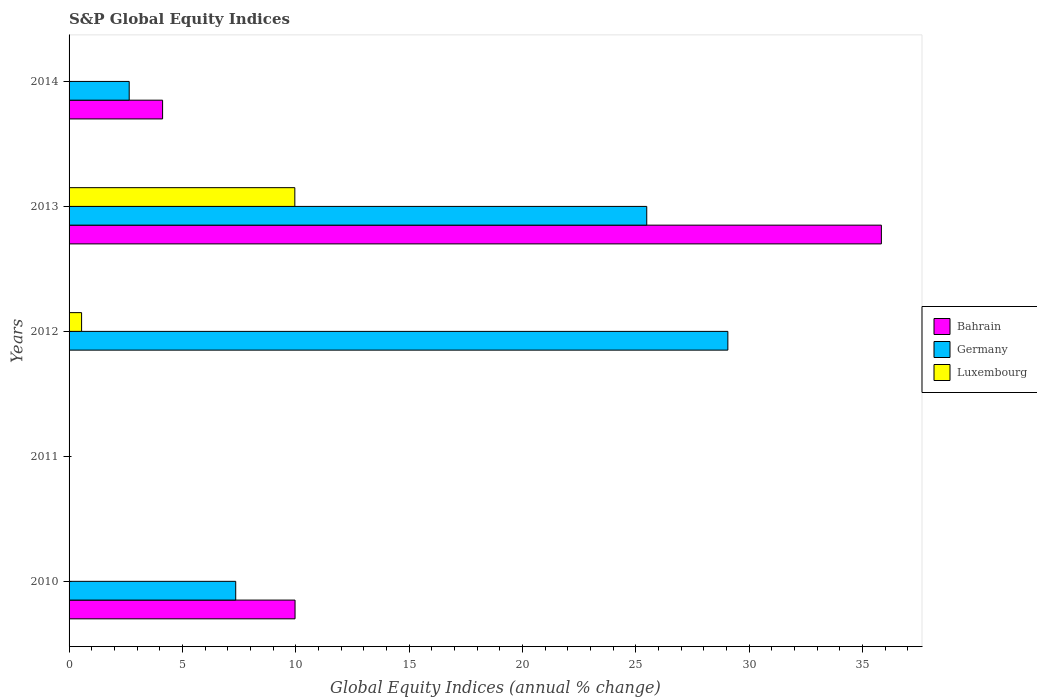In how many cases, is the number of bars for a given year not equal to the number of legend labels?
Provide a succinct answer. 4. Across all years, what is the maximum global equity indices in Germany?
Make the answer very short. 29.06. Across all years, what is the minimum global equity indices in Luxembourg?
Give a very brief answer. 0. In which year was the global equity indices in Luxembourg maximum?
Provide a succinct answer. 2013. What is the total global equity indices in Bahrain in the graph?
Keep it short and to the point. 49.92. What is the difference between the global equity indices in Germany in 2012 and that in 2014?
Provide a short and direct response. 26.41. What is the difference between the global equity indices in Bahrain in 2014 and the global equity indices in Luxembourg in 2012?
Offer a very short reply. 3.57. What is the average global equity indices in Germany per year?
Offer a very short reply. 12.91. In the year 2013, what is the difference between the global equity indices in Luxembourg and global equity indices in Bahrain?
Your answer should be very brief. -25.87. In how many years, is the global equity indices in Bahrain greater than 36 %?
Offer a terse response. 0. What is the ratio of the global equity indices in Germany in 2010 to that in 2013?
Provide a succinct answer. 0.29. What is the difference between the highest and the second highest global equity indices in Germany?
Your answer should be very brief. 3.58. What is the difference between the highest and the lowest global equity indices in Bahrain?
Your answer should be very brief. 35.83. Is it the case that in every year, the sum of the global equity indices in Bahrain and global equity indices in Germany is greater than the global equity indices in Luxembourg?
Your response must be concise. No. How many bars are there?
Your answer should be compact. 9. Are all the bars in the graph horizontal?
Make the answer very short. Yes. How many years are there in the graph?
Offer a terse response. 5. Does the graph contain grids?
Keep it short and to the point. No. How many legend labels are there?
Offer a very short reply. 3. What is the title of the graph?
Your answer should be compact. S&P Global Equity Indices. Does "Upper middle income" appear as one of the legend labels in the graph?
Offer a terse response. No. What is the label or title of the X-axis?
Ensure brevity in your answer.  Global Equity Indices (annual % change). What is the Global Equity Indices (annual % change) of Bahrain in 2010?
Your answer should be very brief. 9.97. What is the Global Equity Indices (annual % change) of Germany in 2010?
Your answer should be compact. 7.35. What is the Global Equity Indices (annual % change) of Luxembourg in 2010?
Provide a short and direct response. 0. What is the Global Equity Indices (annual % change) of Bahrain in 2011?
Provide a succinct answer. 0. What is the Global Equity Indices (annual % change) of Germany in 2011?
Offer a terse response. 0. What is the Global Equity Indices (annual % change) of Luxembourg in 2011?
Your answer should be very brief. 0. What is the Global Equity Indices (annual % change) in Germany in 2012?
Make the answer very short. 29.06. What is the Global Equity Indices (annual % change) of Luxembourg in 2012?
Ensure brevity in your answer.  0.55. What is the Global Equity Indices (annual % change) of Bahrain in 2013?
Give a very brief answer. 35.83. What is the Global Equity Indices (annual % change) in Germany in 2013?
Your answer should be compact. 25.48. What is the Global Equity Indices (annual % change) in Luxembourg in 2013?
Make the answer very short. 9.96. What is the Global Equity Indices (annual % change) of Bahrain in 2014?
Provide a succinct answer. 4.13. What is the Global Equity Indices (annual % change) in Germany in 2014?
Offer a very short reply. 2.65. What is the Global Equity Indices (annual % change) in Luxembourg in 2014?
Your answer should be very brief. 0. Across all years, what is the maximum Global Equity Indices (annual % change) in Bahrain?
Make the answer very short. 35.83. Across all years, what is the maximum Global Equity Indices (annual % change) of Germany?
Your answer should be very brief. 29.06. Across all years, what is the maximum Global Equity Indices (annual % change) of Luxembourg?
Make the answer very short. 9.96. Across all years, what is the minimum Global Equity Indices (annual % change) of Germany?
Give a very brief answer. 0. What is the total Global Equity Indices (annual % change) of Bahrain in the graph?
Keep it short and to the point. 49.92. What is the total Global Equity Indices (annual % change) in Germany in the graph?
Offer a terse response. 64.54. What is the total Global Equity Indices (annual % change) in Luxembourg in the graph?
Your response must be concise. 10.51. What is the difference between the Global Equity Indices (annual % change) of Germany in 2010 and that in 2012?
Provide a short and direct response. -21.71. What is the difference between the Global Equity Indices (annual % change) in Bahrain in 2010 and that in 2013?
Your response must be concise. -25.86. What is the difference between the Global Equity Indices (annual % change) of Germany in 2010 and that in 2013?
Make the answer very short. -18.13. What is the difference between the Global Equity Indices (annual % change) of Bahrain in 2010 and that in 2014?
Keep it short and to the point. 5.84. What is the difference between the Global Equity Indices (annual % change) of Germany in 2010 and that in 2014?
Your answer should be very brief. 4.7. What is the difference between the Global Equity Indices (annual % change) of Germany in 2012 and that in 2013?
Ensure brevity in your answer.  3.58. What is the difference between the Global Equity Indices (annual % change) of Luxembourg in 2012 and that in 2013?
Provide a short and direct response. -9.41. What is the difference between the Global Equity Indices (annual % change) of Germany in 2012 and that in 2014?
Your answer should be very brief. 26.41. What is the difference between the Global Equity Indices (annual % change) of Bahrain in 2013 and that in 2014?
Give a very brief answer. 31.71. What is the difference between the Global Equity Indices (annual % change) of Germany in 2013 and that in 2014?
Give a very brief answer. 22.83. What is the difference between the Global Equity Indices (annual % change) of Bahrain in 2010 and the Global Equity Indices (annual % change) of Germany in 2012?
Make the answer very short. -19.09. What is the difference between the Global Equity Indices (annual % change) in Bahrain in 2010 and the Global Equity Indices (annual % change) in Luxembourg in 2012?
Your response must be concise. 9.42. What is the difference between the Global Equity Indices (annual % change) in Germany in 2010 and the Global Equity Indices (annual % change) in Luxembourg in 2012?
Make the answer very short. 6.8. What is the difference between the Global Equity Indices (annual % change) in Bahrain in 2010 and the Global Equity Indices (annual % change) in Germany in 2013?
Provide a short and direct response. -15.51. What is the difference between the Global Equity Indices (annual % change) of Bahrain in 2010 and the Global Equity Indices (annual % change) of Luxembourg in 2013?
Provide a succinct answer. 0.01. What is the difference between the Global Equity Indices (annual % change) in Germany in 2010 and the Global Equity Indices (annual % change) in Luxembourg in 2013?
Offer a very short reply. -2.61. What is the difference between the Global Equity Indices (annual % change) of Bahrain in 2010 and the Global Equity Indices (annual % change) of Germany in 2014?
Give a very brief answer. 7.32. What is the difference between the Global Equity Indices (annual % change) in Germany in 2012 and the Global Equity Indices (annual % change) in Luxembourg in 2013?
Your answer should be compact. 19.1. What is the difference between the Global Equity Indices (annual % change) of Bahrain in 2013 and the Global Equity Indices (annual % change) of Germany in 2014?
Offer a very short reply. 33.18. What is the average Global Equity Indices (annual % change) in Bahrain per year?
Ensure brevity in your answer.  9.98. What is the average Global Equity Indices (annual % change) in Germany per year?
Provide a succinct answer. 12.91. What is the average Global Equity Indices (annual % change) of Luxembourg per year?
Your answer should be compact. 2.1. In the year 2010, what is the difference between the Global Equity Indices (annual % change) of Bahrain and Global Equity Indices (annual % change) of Germany?
Your answer should be very brief. 2.62. In the year 2012, what is the difference between the Global Equity Indices (annual % change) in Germany and Global Equity Indices (annual % change) in Luxembourg?
Make the answer very short. 28.51. In the year 2013, what is the difference between the Global Equity Indices (annual % change) of Bahrain and Global Equity Indices (annual % change) of Germany?
Provide a short and direct response. 10.35. In the year 2013, what is the difference between the Global Equity Indices (annual % change) of Bahrain and Global Equity Indices (annual % change) of Luxembourg?
Make the answer very short. 25.87. In the year 2013, what is the difference between the Global Equity Indices (annual % change) in Germany and Global Equity Indices (annual % change) in Luxembourg?
Ensure brevity in your answer.  15.52. In the year 2014, what is the difference between the Global Equity Indices (annual % change) in Bahrain and Global Equity Indices (annual % change) in Germany?
Provide a succinct answer. 1.47. What is the ratio of the Global Equity Indices (annual % change) in Germany in 2010 to that in 2012?
Ensure brevity in your answer.  0.25. What is the ratio of the Global Equity Indices (annual % change) of Bahrain in 2010 to that in 2013?
Make the answer very short. 0.28. What is the ratio of the Global Equity Indices (annual % change) in Germany in 2010 to that in 2013?
Your answer should be compact. 0.29. What is the ratio of the Global Equity Indices (annual % change) of Bahrain in 2010 to that in 2014?
Make the answer very short. 2.42. What is the ratio of the Global Equity Indices (annual % change) in Germany in 2010 to that in 2014?
Provide a succinct answer. 2.77. What is the ratio of the Global Equity Indices (annual % change) in Germany in 2012 to that in 2013?
Offer a terse response. 1.14. What is the ratio of the Global Equity Indices (annual % change) of Luxembourg in 2012 to that in 2013?
Give a very brief answer. 0.06. What is the ratio of the Global Equity Indices (annual % change) of Germany in 2012 to that in 2014?
Keep it short and to the point. 10.95. What is the ratio of the Global Equity Indices (annual % change) of Bahrain in 2013 to that in 2014?
Provide a succinct answer. 8.68. What is the ratio of the Global Equity Indices (annual % change) of Germany in 2013 to that in 2014?
Keep it short and to the point. 9.61. What is the difference between the highest and the second highest Global Equity Indices (annual % change) in Bahrain?
Provide a succinct answer. 25.86. What is the difference between the highest and the second highest Global Equity Indices (annual % change) of Germany?
Provide a short and direct response. 3.58. What is the difference between the highest and the lowest Global Equity Indices (annual % change) of Bahrain?
Offer a very short reply. 35.83. What is the difference between the highest and the lowest Global Equity Indices (annual % change) of Germany?
Provide a short and direct response. 29.06. What is the difference between the highest and the lowest Global Equity Indices (annual % change) of Luxembourg?
Ensure brevity in your answer.  9.96. 